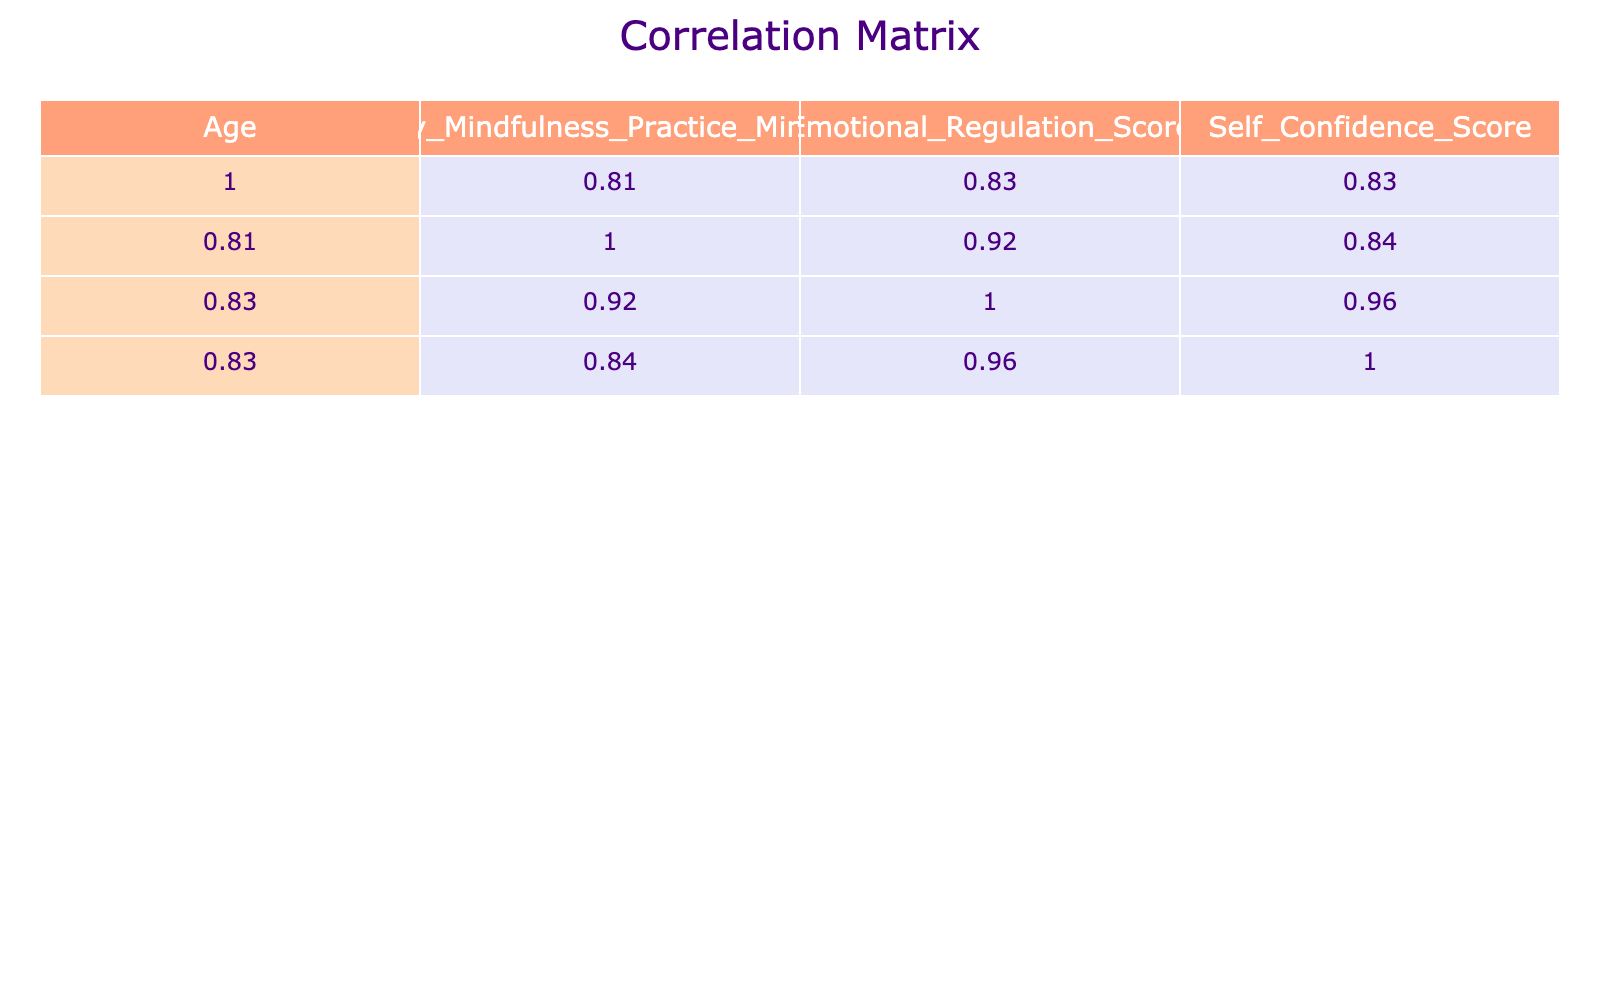What is the emotional regulation score of Ava? By referring to the table, we can find Ava's row, which shows that her emotional regulation score is 88.
Answer: 88 What is the average self-confidence score of the children in the table? To calculate the average self-confidence score, we need to sum all self-confidence scores: (85 + 90 + 80 + 92 + 75 + 88 + 82 + 94 + 80 + 87) = 87.8. Then, divide by the number of children (10), which results in 87.8/10 = 87.8.
Answer: 87.8 Is Harper's emotional regulation score higher than Mia's? Harper's emotional regulation score is 90, and Mia's score is 82. Since 90 is greater than 82, the answer is yes.
Answer: Yes Which child has the highest daily mindfulness practice minutes, and what is the score of emotional regulation for that child? Harper practices mindfulness for 40 minutes, which is the highest. Her emotional regulation score is 90.
Answer: Harper, 90 What is the correlation between daily mindfulness practice minutes and self-confidence scores? To determine this, we assess the correlation coefficient in the table under the relevant columns, which indicates a positive correlation of 0.92. This implies a strong relationship, suggesting that increased mindfulness practice is associated with higher self-confidence.
Answer: 0.92 